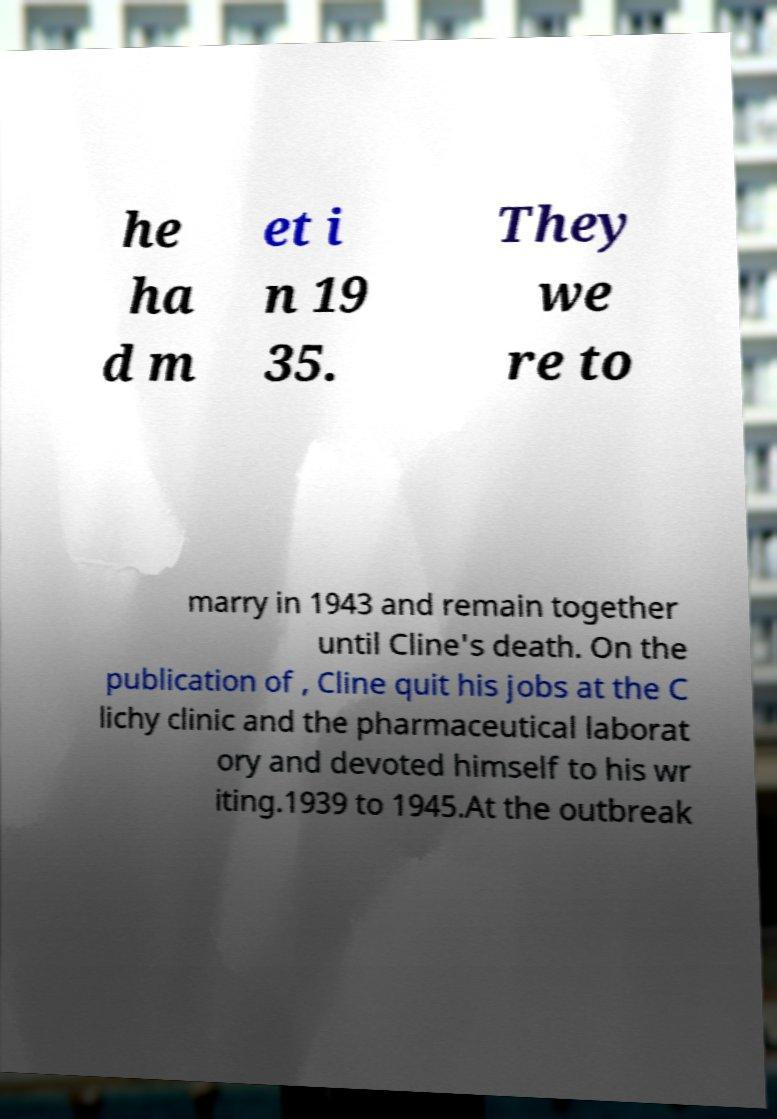Could you extract and type out the text from this image? he ha d m et i n 19 35. They we re to marry in 1943 and remain together until Cline's death. On the publication of , Cline quit his jobs at the C lichy clinic and the pharmaceutical laborat ory and devoted himself to his wr iting.1939 to 1945.At the outbreak 